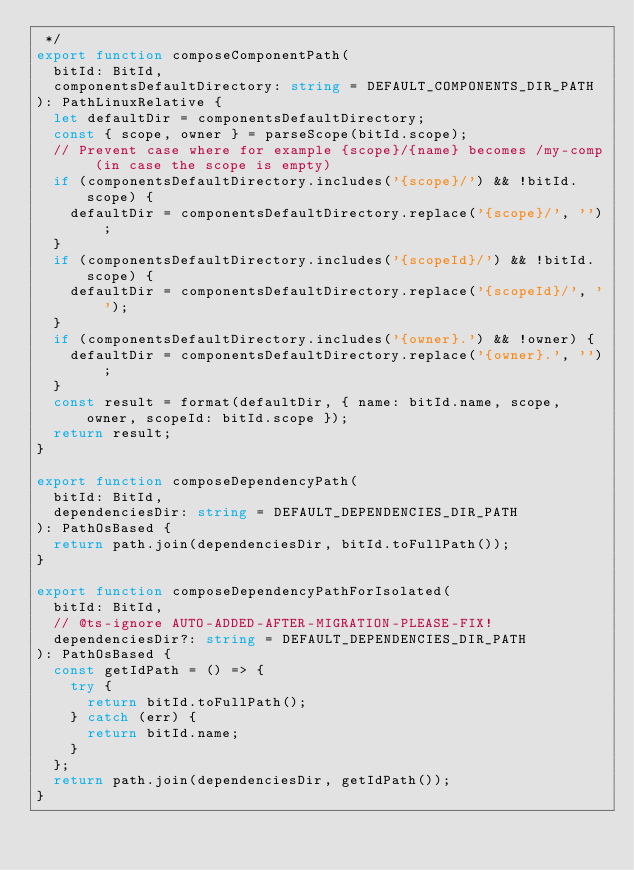Convert code to text. <code><loc_0><loc_0><loc_500><loc_500><_TypeScript_> */
export function composeComponentPath(
  bitId: BitId,
  componentsDefaultDirectory: string = DEFAULT_COMPONENTS_DIR_PATH
): PathLinuxRelative {
  let defaultDir = componentsDefaultDirectory;
  const { scope, owner } = parseScope(bitId.scope);
  // Prevent case where for example {scope}/{name} becomes /my-comp (in case the scope is empty)
  if (componentsDefaultDirectory.includes('{scope}/') && !bitId.scope) {
    defaultDir = componentsDefaultDirectory.replace('{scope}/', '');
  }
  if (componentsDefaultDirectory.includes('{scopeId}/') && !bitId.scope) {
    defaultDir = componentsDefaultDirectory.replace('{scopeId}/', '');
  }
  if (componentsDefaultDirectory.includes('{owner}.') && !owner) {
    defaultDir = componentsDefaultDirectory.replace('{owner}.', '');
  }
  const result = format(defaultDir, { name: bitId.name, scope, owner, scopeId: bitId.scope });
  return result;
}

export function composeDependencyPath(
  bitId: BitId,
  dependenciesDir: string = DEFAULT_DEPENDENCIES_DIR_PATH
): PathOsBased {
  return path.join(dependenciesDir, bitId.toFullPath());
}

export function composeDependencyPathForIsolated(
  bitId: BitId,
  // @ts-ignore AUTO-ADDED-AFTER-MIGRATION-PLEASE-FIX!
  dependenciesDir?: string = DEFAULT_DEPENDENCIES_DIR_PATH
): PathOsBased {
  const getIdPath = () => {
    try {
      return bitId.toFullPath();
    } catch (err) {
      return bitId.name;
    }
  };
  return path.join(dependenciesDir, getIdPath());
}
</code> 